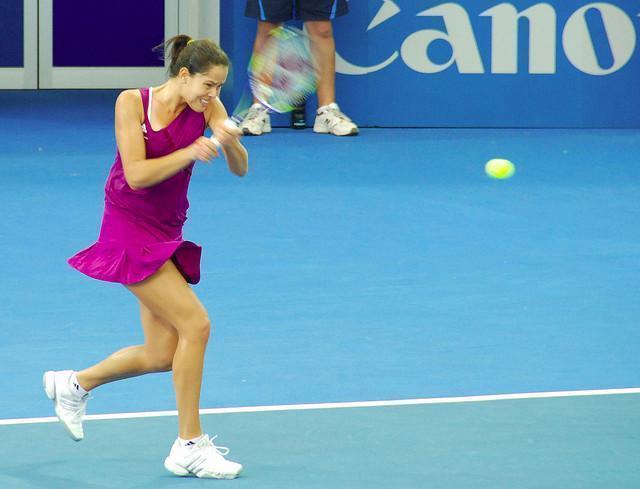What is the most likely reason for the word appearing on the wall behind the athlete?
Choose the correct response, then elucidate: 'Answer: answer
Rationale: rationale.'
Options: Paid advertisement, player name, instructions, tournament name. Answer: paid advertisement.
Rationale: It's a paid ad. 